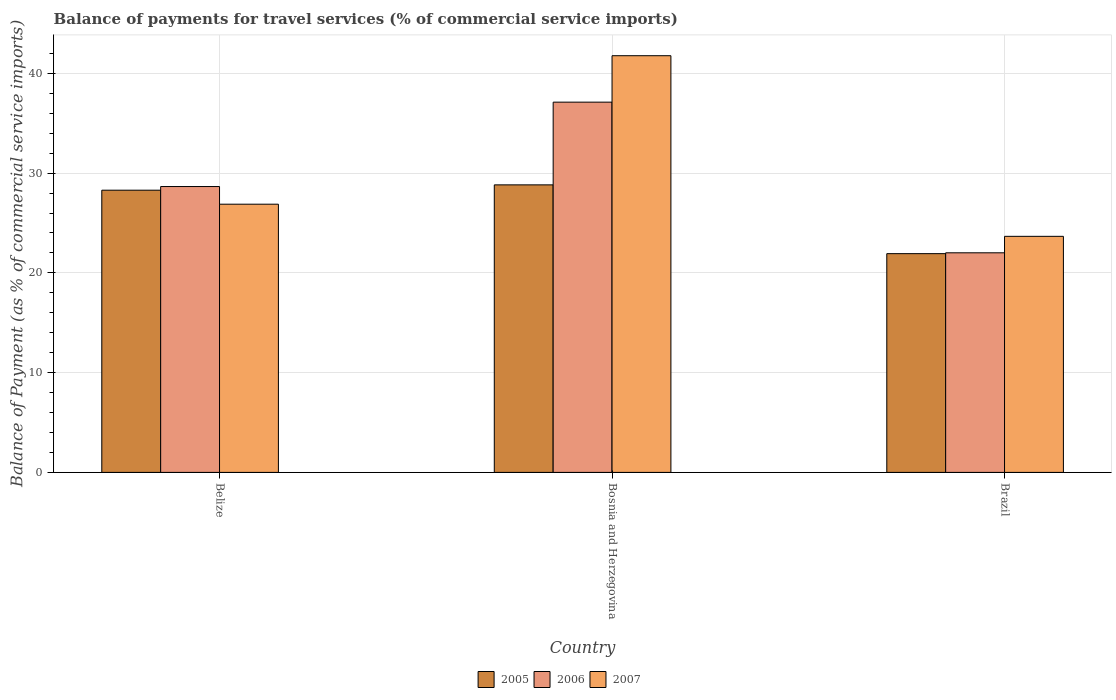How many different coloured bars are there?
Make the answer very short. 3. How many groups of bars are there?
Keep it short and to the point. 3. Are the number of bars per tick equal to the number of legend labels?
Offer a very short reply. Yes. How many bars are there on the 2nd tick from the right?
Provide a short and direct response. 3. What is the label of the 1st group of bars from the left?
Offer a very short reply. Belize. In how many cases, is the number of bars for a given country not equal to the number of legend labels?
Your answer should be very brief. 0. What is the balance of payments for travel services in 2007 in Bosnia and Herzegovina?
Provide a succinct answer. 41.77. Across all countries, what is the maximum balance of payments for travel services in 2006?
Your response must be concise. 37.12. Across all countries, what is the minimum balance of payments for travel services in 2006?
Provide a short and direct response. 22.01. In which country was the balance of payments for travel services in 2006 maximum?
Your response must be concise. Bosnia and Herzegovina. In which country was the balance of payments for travel services in 2005 minimum?
Ensure brevity in your answer.  Brazil. What is the total balance of payments for travel services in 2006 in the graph?
Give a very brief answer. 87.78. What is the difference between the balance of payments for travel services in 2006 in Belize and that in Brazil?
Your answer should be very brief. 6.64. What is the difference between the balance of payments for travel services in 2006 in Belize and the balance of payments for travel services in 2007 in Brazil?
Keep it short and to the point. 4.99. What is the average balance of payments for travel services in 2007 per country?
Offer a very short reply. 30.77. What is the difference between the balance of payments for travel services of/in 2006 and balance of payments for travel services of/in 2007 in Brazil?
Your answer should be very brief. -1.65. In how many countries, is the balance of payments for travel services in 2007 greater than 24 %?
Provide a succinct answer. 2. What is the ratio of the balance of payments for travel services in 2006 in Belize to that in Brazil?
Make the answer very short. 1.3. Is the balance of payments for travel services in 2006 in Belize less than that in Brazil?
Offer a very short reply. No. Is the difference between the balance of payments for travel services in 2006 in Belize and Bosnia and Herzegovina greater than the difference between the balance of payments for travel services in 2007 in Belize and Bosnia and Herzegovina?
Keep it short and to the point. Yes. What is the difference between the highest and the second highest balance of payments for travel services in 2005?
Ensure brevity in your answer.  -6.9. What is the difference between the highest and the lowest balance of payments for travel services in 2005?
Provide a succinct answer. 6.9. In how many countries, is the balance of payments for travel services in 2006 greater than the average balance of payments for travel services in 2006 taken over all countries?
Make the answer very short. 1. What does the 2nd bar from the left in Bosnia and Herzegovina represents?
Provide a succinct answer. 2006. Is it the case that in every country, the sum of the balance of payments for travel services in 2006 and balance of payments for travel services in 2005 is greater than the balance of payments for travel services in 2007?
Ensure brevity in your answer.  Yes. How many bars are there?
Ensure brevity in your answer.  9. Are all the bars in the graph horizontal?
Give a very brief answer. No. How many countries are there in the graph?
Provide a short and direct response. 3. Are the values on the major ticks of Y-axis written in scientific E-notation?
Provide a short and direct response. No. Does the graph contain grids?
Your response must be concise. Yes. How many legend labels are there?
Your response must be concise. 3. How are the legend labels stacked?
Provide a succinct answer. Horizontal. What is the title of the graph?
Keep it short and to the point. Balance of payments for travel services (% of commercial service imports). Does "2014" appear as one of the legend labels in the graph?
Provide a short and direct response. No. What is the label or title of the Y-axis?
Your answer should be compact. Balance of Payment (as % of commercial service imports). What is the Balance of Payment (as % of commercial service imports) in 2005 in Belize?
Your answer should be very brief. 28.29. What is the Balance of Payment (as % of commercial service imports) in 2006 in Belize?
Your answer should be compact. 28.66. What is the Balance of Payment (as % of commercial service imports) in 2007 in Belize?
Your answer should be very brief. 26.89. What is the Balance of Payment (as % of commercial service imports) of 2005 in Bosnia and Herzegovina?
Provide a short and direct response. 28.82. What is the Balance of Payment (as % of commercial service imports) of 2006 in Bosnia and Herzegovina?
Give a very brief answer. 37.12. What is the Balance of Payment (as % of commercial service imports) of 2007 in Bosnia and Herzegovina?
Your answer should be compact. 41.77. What is the Balance of Payment (as % of commercial service imports) of 2005 in Brazil?
Provide a succinct answer. 21.93. What is the Balance of Payment (as % of commercial service imports) in 2006 in Brazil?
Your answer should be compact. 22.01. What is the Balance of Payment (as % of commercial service imports) of 2007 in Brazil?
Your answer should be very brief. 23.66. Across all countries, what is the maximum Balance of Payment (as % of commercial service imports) of 2005?
Provide a succinct answer. 28.82. Across all countries, what is the maximum Balance of Payment (as % of commercial service imports) in 2006?
Your answer should be very brief. 37.12. Across all countries, what is the maximum Balance of Payment (as % of commercial service imports) of 2007?
Give a very brief answer. 41.77. Across all countries, what is the minimum Balance of Payment (as % of commercial service imports) of 2005?
Give a very brief answer. 21.93. Across all countries, what is the minimum Balance of Payment (as % of commercial service imports) in 2006?
Keep it short and to the point. 22.01. Across all countries, what is the minimum Balance of Payment (as % of commercial service imports) in 2007?
Provide a succinct answer. 23.66. What is the total Balance of Payment (as % of commercial service imports) in 2005 in the graph?
Offer a terse response. 79.04. What is the total Balance of Payment (as % of commercial service imports) of 2006 in the graph?
Ensure brevity in your answer.  87.78. What is the total Balance of Payment (as % of commercial service imports) in 2007 in the graph?
Make the answer very short. 92.32. What is the difference between the Balance of Payment (as % of commercial service imports) in 2005 in Belize and that in Bosnia and Herzegovina?
Offer a terse response. -0.53. What is the difference between the Balance of Payment (as % of commercial service imports) of 2006 in Belize and that in Bosnia and Herzegovina?
Provide a succinct answer. -8.46. What is the difference between the Balance of Payment (as % of commercial service imports) in 2007 in Belize and that in Bosnia and Herzegovina?
Your answer should be very brief. -14.88. What is the difference between the Balance of Payment (as % of commercial service imports) of 2005 in Belize and that in Brazil?
Make the answer very short. 6.36. What is the difference between the Balance of Payment (as % of commercial service imports) in 2006 in Belize and that in Brazil?
Your answer should be very brief. 6.64. What is the difference between the Balance of Payment (as % of commercial service imports) in 2007 in Belize and that in Brazil?
Provide a succinct answer. 3.22. What is the difference between the Balance of Payment (as % of commercial service imports) in 2005 in Bosnia and Herzegovina and that in Brazil?
Provide a short and direct response. 6.9. What is the difference between the Balance of Payment (as % of commercial service imports) of 2006 in Bosnia and Herzegovina and that in Brazil?
Keep it short and to the point. 15.1. What is the difference between the Balance of Payment (as % of commercial service imports) of 2007 in Bosnia and Herzegovina and that in Brazil?
Your response must be concise. 18.11. What is the difference between the Balance of Payment (as % of commercial service imports) of 2005 in Belize and the Balance of Payment (as % of commercial service imports) of 2006 in Bosnia and Herzegovina?
Your answer should be very brief. -8.83. What is the difference between the Balance of Payment (as % of commercial service imports) of 2005 in Belize and the Balance of Payment (as % of commercial service imports) of 2007 in Bosnia and Herzegovina?
Offer a terse response. -13.48. What is the difference between the Balance of Payment (as % of commercial service imports) in 2006 in Belize and the Balance of Payment (as % of commercial service imports) in 2007 in Bosnia and Herzegovina?
Keep it short and to the point. -13.12. What is the difference between the Balance of Payment (as % of commercial service imports) in 2005 in Belize and the Balance of Payment (as % of commercial service imports) in 2006 in Brazil?
Give a very brief answer. 6.28. What is the difference between the Balance of Payment (as % of commercial service imports) of 2005 in Belize and the Balance of Payment (as % of commercial service imports) of 2007 in Brazil?
Your response must be concise. 4.63. What is the difference between the Balance of Payment (as % of commercial service imports) of 2006 in Belize and the Balance of Payment (as % of commercial service imports) of 2007 in Brazil?
Offer a very short reply. 4.99. What is the difference between the Balance of Payment (as % of commercial service imports) of 2005 in Bosnia and Herzegovina and the Balance of Payment (as % of commercial service imports) of 2006 in Brazil?
Your answer should be very brief. 6.81. What is the difference between the Balance of Payment (as % of commercial service imports) in 2005 in Bosnia and Herzegovina and the Balance of Payment (as % of commercial service imports) in 2007 in Brazil?
Your response must be concise. 5.16. What is the difference between the Balance of Payment (as % of commercial service imports) in 2006 in Bosnia and Herzegovina and the Balance of Payment (as % of commercial service imports) in 2007 in Brazil?
Give a very brief answer. 13.45. What is the average Balance of Payment (as % of commercial service imports) of 2005 per country?
Provide a short and direct response. 26.35. What is the average Balance of Payment (as % of commercial service imports) in 2006 per country?
Give a very brief answer. 29.26. What is the average Balance of Payment (as % of commercial service imports) of 2007 per country?
Keep it short and to the point. 30.77. What is the difference between the Balance of Payment (as % of commercial service imports) of 2005 and Balance of Payment (as % of commercial service imports) of 2006 in Belize?
Provide a short and direct response. -0.37. What is the difference between the Balance of Payment (as % of commercial service imports) in 2005 and Balance of Payment (as % of commercial service imports) in 2007 in Belize?
Make the answer very short. 1.4. What is the difference between the Balance of Payment (as % of commercial service imports) in 2006 and Balance of Payment (as % of commercial service imports) in 2007 in Belize?
Offer a terse response. 1.77. What is the difference between the Balance of Payment (as % of commercial service imports) of 2005 and Balance of Payment (as % of commercial service imports) of 2006 in Bosnia and Herzegovina?
Keep it short and to the point. -8.29. What is the difference between the Balance of Payment (as % of commercial service imports) of 2005 and Balance of Payment (as % of commercial service imports) of 2007 in Bosnia and Herzegovina?
Your response must be concise. -12.95. What is the difference between the Balance of Payment (as % of commercial service imports) in 2006 and Balance of Payment (as % of commercial service imports) in 2007 in Bosnia and Herzegovina?
Keep it short and to the point. -4.66. What is the difference between the Balance of Payment (as % of commercial service imports) of 2005 and Balance of Payment (as % of commercial service imports) of 2006 in Brazil?
Provide a short and direct response. -0.09. What is the difference between the Balance of Payment (as % of commercial service imports) of 2005 and Balance of Payment (as % of commercial service imports) of 2007 in Brazil?
Offer a very short reply. -1.74. What is the difference between the Balance of Payment (as % of commercial service imports) of 2006 and Balance of Payment (as % of commercial service imports) of 2007 in Brazil?
Your answer should be very brief. -1.65. What is the ratio of the Balance of Payment (as % of commercial service imports) of 2005 in Belize to that in Bosnia and Herzegovina?
Provide a short and direct response. 0.98. What is the ratio of the Balance of Payment (as % of commercial service imports) in 2006 in Belize to that in Bosnia and Herzegovina?
Give a very brief answer. 0.77. What is the ratio of the Balance of Payment (as % of commercial service imports) in 2007 in Belize to that in Bosnia and Herzegovina?
Give a very brief answer. 0.64. What is the ratio of the Balance of Payment (as % of commercial service imports) of 2005 in Belize to that in Brazil?
Provide a short and direct response. 1.29. What is the ratio of the Balance of Payment (as % of commercial service imports) of 2006 in Belize to that in Brazil?
Your response must be concise. 1.3. What is the ratio of the Balance of Payment (as % of commercial service imports) in 2007 in Belize to that in Brazil?
Your response must be concise. 1.14. What is the ratio of the Balance of Payment (as % of commercial service imports) of 2005 in Bosnia and Herzegovina to that in Brazil?
Offer a very short reply. 1.31. What is the ratio of the Balance of Payment (as % of commercial service imports) of 2006 in Bosnia and Herzegovina to that in Brazil?
Offer a very short reply. 1.69. What is the ratio of the Balance of Payment (as % of commercial service imports) in 2007 in Bosnia and Herzegovina to that in Brazil?
Ensure brevity in your answer.  1.77. What is the difference between the highest and the second highest Balance of Payment (as % of commercial service imports) of 2005?
Give a very brief answer. 0.53. What is the difference between the highest and the second highest Balance of Payment (as % of commercial service imports) of 2006?
Your answer should be very brief. 8.46. What is the difference between the highest and the second highest Balance of Payment (as % of commercial service imports) in 2007?
Offer a terse response. 14.88. What is the difference between the highest and the lowest Balance of Payment (as % of commercial service imports) in 2005?
Keep it short and to the point. 6.9. What is the difference between the highest and the lowest Balance of Payment (as % of commercial service imports) in 2006?
Keep it short and to the point. 15.1. What is the difference between the highest and the lowest Balance of Payment (as % of commercial service imports) of 2007?
Your answer should be compact. 18.11. 